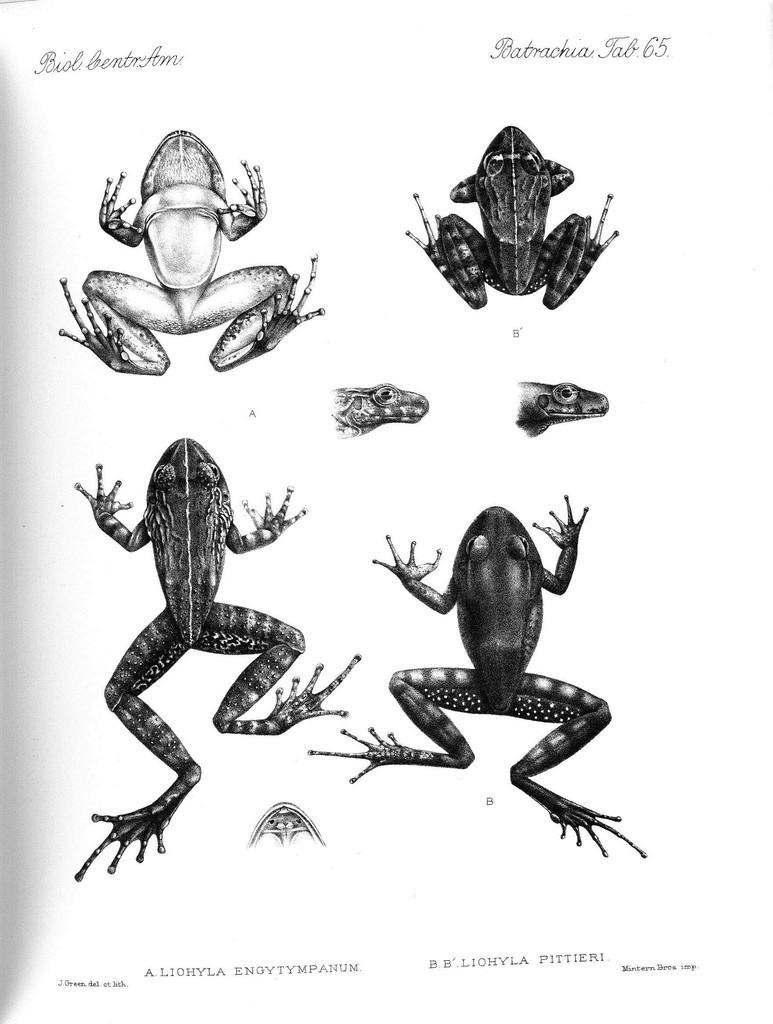Could you give a brief overview of what you see in this image? In this picture we can observe four different types of frogs. Three of them were in dark color and the other one was in light color. All of these were sketches of the frogs on the paper. We can observe other two animals on the paper. 